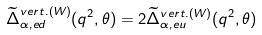Convert formula to latex. <formula><loc_0><loc_0><loc_500><loc_500>\widetilde { \Delta } ^ { v e r t . ( W ) } _ { \alpha , e d } ( q ^ { 2 } , \theta ) = 2 \widetilde { \Delta } ^ { v e r t . ( W ) } _ { \alpha , e u } ( q ^ { 2 } , \theta )</formula> 